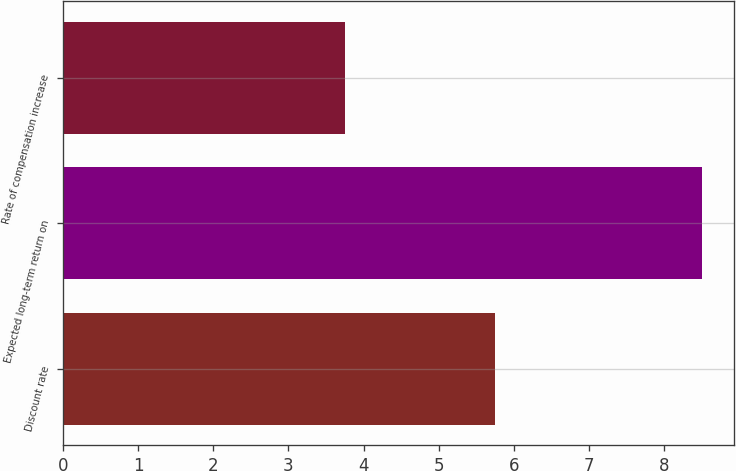<chart> <loc_0><loc_0><loc_500><loc_500><bar_chart><fcel>Discount rate<fcel>Expected long-term return on<fcel>Rate of compensation increase<nl><fcel>5.75<fcel>8.5<fcel>3.75<nl></chart> 